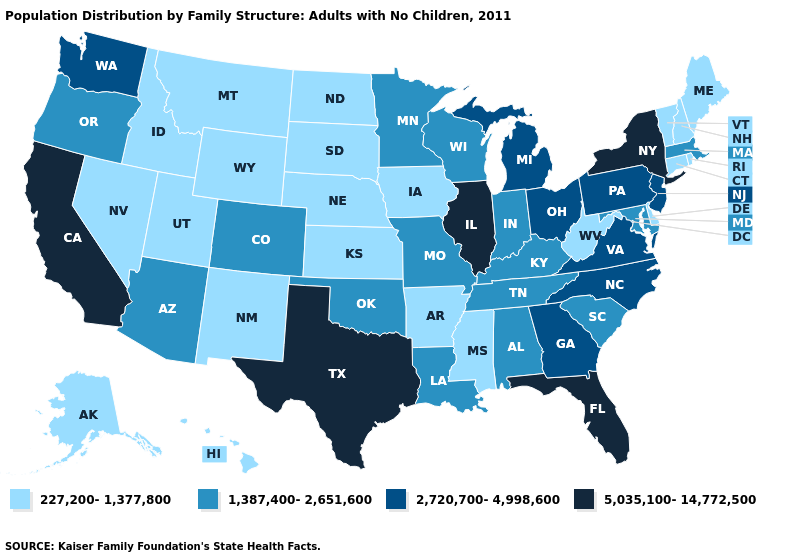Does Kentucky have a lower value than Indiana?
Write a very short answer. No. Which states hav the highest value in the West?
Answer briefly. California. Is the legend a continuous bar?
Short answer required. No. Does Massachusetts have the highest value in the Northeast?
Answer briefly. No. Among the states that border Massachusetts , which have the highest value?
Be succinct. New York. Does Illinois have the lowest value in the USA?
Be succinct. No. Does Florida have the highest value in the South?
Short answer required. Yes. What is the value of Connecticut?
Give a very brief answer. 227,200-1,377,800. How many symbols are there in the legend?
Give a very brief answer. 4. Name the states that have a value in the range 1,387,400-2,651,600?
Short answer required. Alabama, Arizona, Colorado, Indiana, Kentucky, Louisiana, Maryland, Massachusetts, Minnesota, Missouri, Oklahoma, Oregon, South Carolina, Tennessee, Wisconsin. Does Mississippi have the same value as Nebraska?
Keep it brief. Yes. Is the legend a continuous bar?
Quick response, please. No. What is the highest value in the USA?
Answer briefly. 5,035,100-14,772,500. Does South Carolina have a higher value than South Dakota?
Be succinct. Yes. Name the states that have a value in the range 227,200-1,377,800?
Write a very short answer. Alaska, Arkansas, Connecticut, Delaware, Hawaii, Idaho, Iowa, Kansas, Maine, Mississippi, Montana, Nebraska, Nevada, New Hampshire, New Mexico, North Dakota, Rhode Island, South Dakota, Utah, Vermont, West Virginia, Wyoming. 